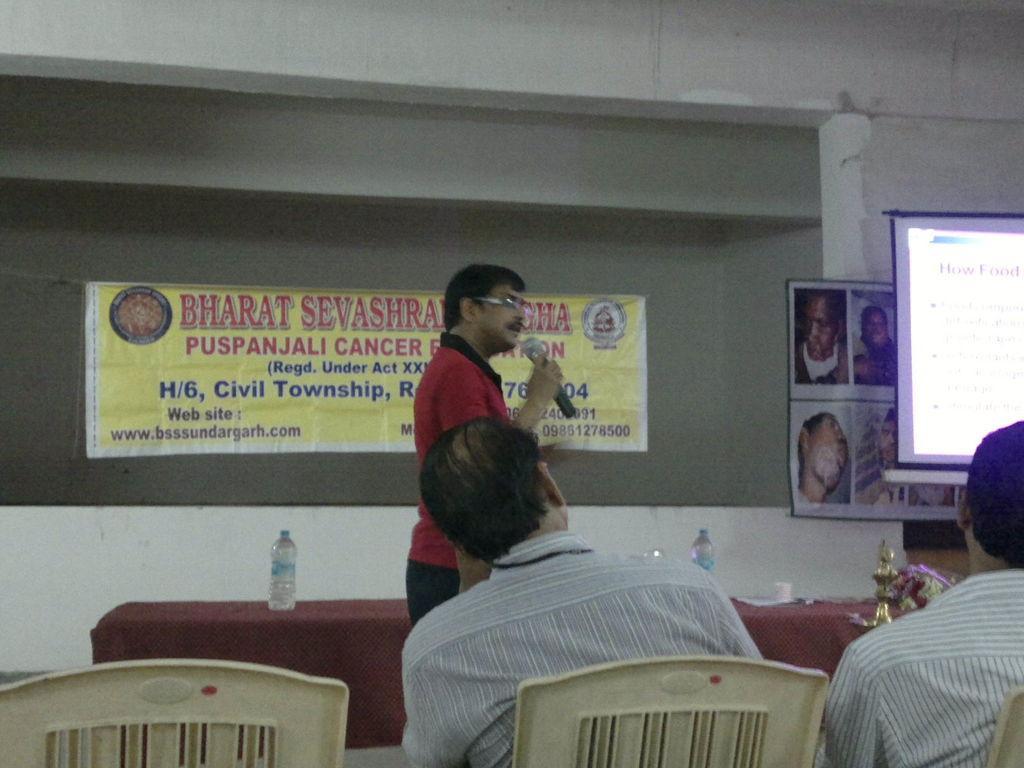Can you describe this image briefly? On the right side, there are two persons sitting on chairs. On the left side, there is a chair. In the background, there is a person in a red color t-shirt, holding a mic with a hand, speaking and standing, beside him, there are bottles and other objects on the table which is covered with a cloth, there is a banner, there is a screen and there is a white wall. 